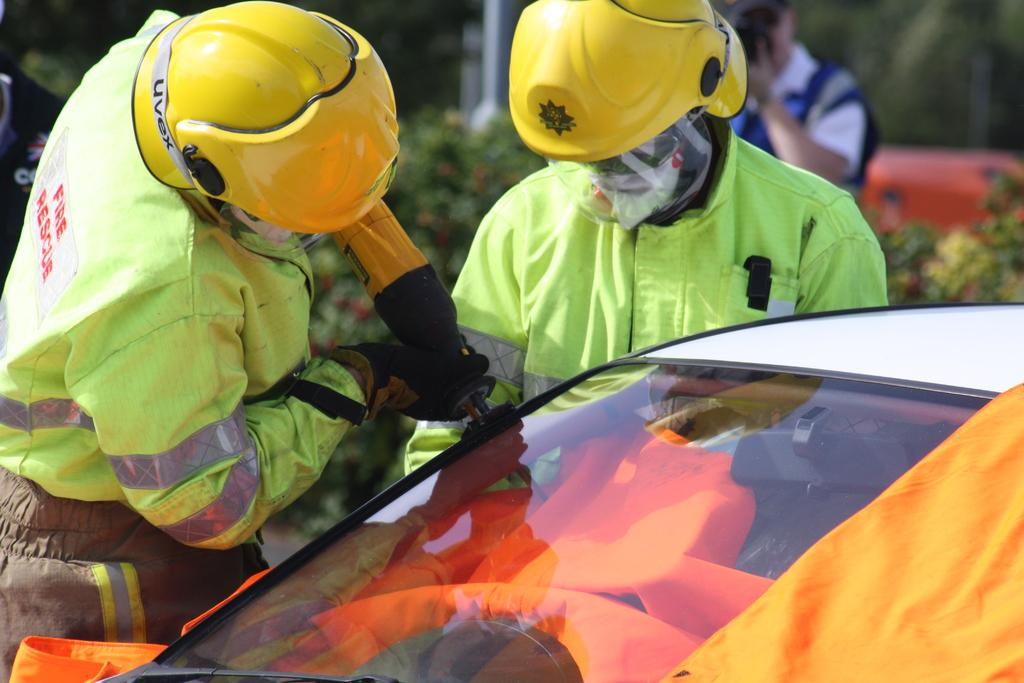What is the main subject of the image? There is a car in the image. Can you describe the people in the image? Two people are visible in the image, and they are holding an object. What can be seen in the background of the image? There are plants and people in the background of the image. What type of current can be seen flowing through the car in the image? There is no current flowing through the car in the image; it is a stationary object. What sound does the whistle make in the image? There is no whistle present in the image. 